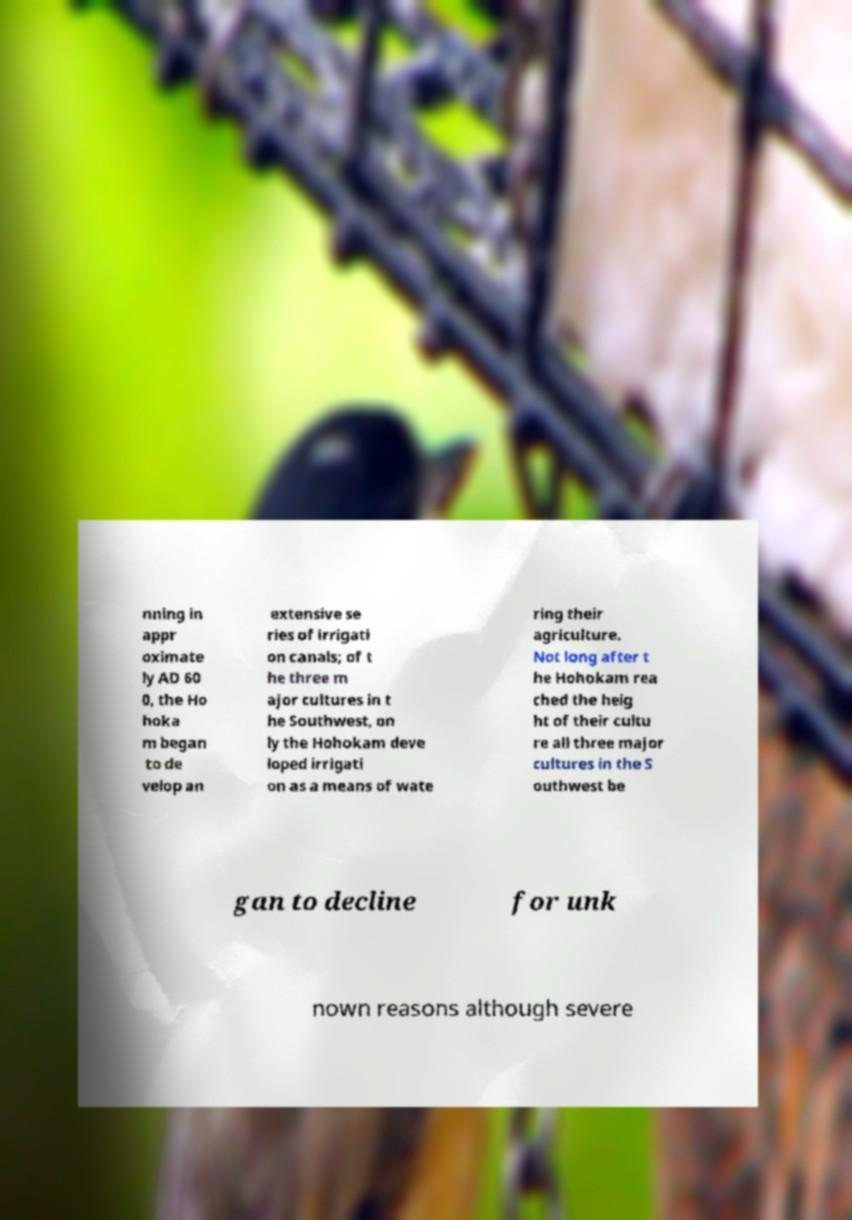Can you accurately transcribe the text from the provided image for me? nning in appr oximate ly AD 60 0, the Ho hoka m began to de velop an extensive se ries of irrigati on canals; of t he three m ajor cultures in t he Southwest, on ly the Hohokam deve loped irrigati on as a means of wate ring their agriculture. Not long after t he Hohokam rea ched the heig ht of their cultu re all three major cultures in the S outhwest be gan to decline for unk nown reasons although severe 